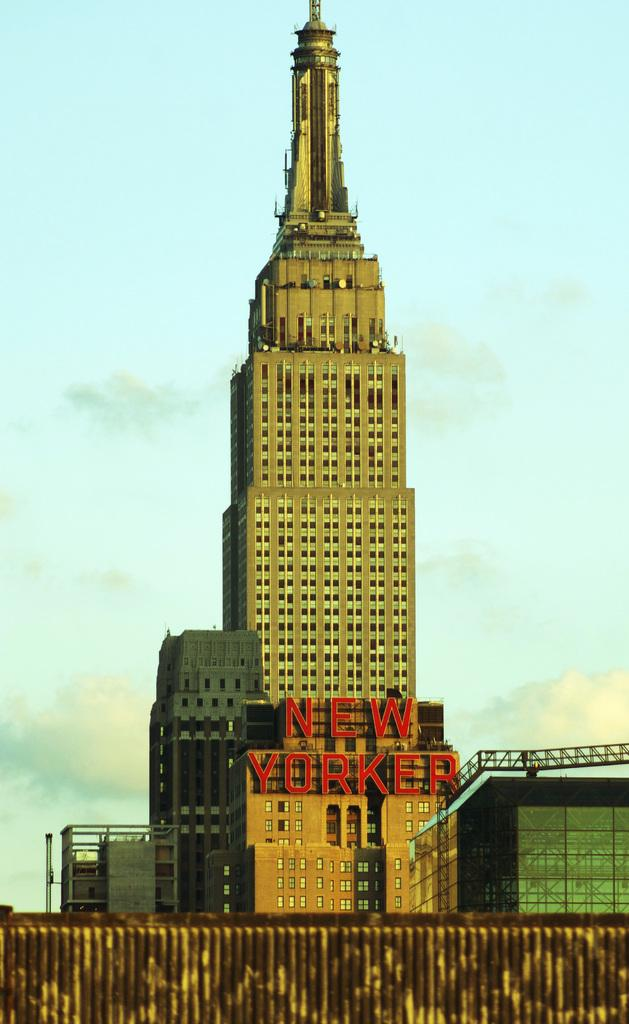What type of structures are present in the image? There are buildings in the image. Can you describe any specific features of one of the buildings? Yes, there is a building with text in the image. What is blocking the view of one of the buildings in the image? There is a wall in front of a building in the image. What can be seen in the distance in the image? The sky is visible in the background of the image. What type of song is being sung by the legs in the image? There are no legs or singing in the image; it features buildings, a wall, and the sky. 